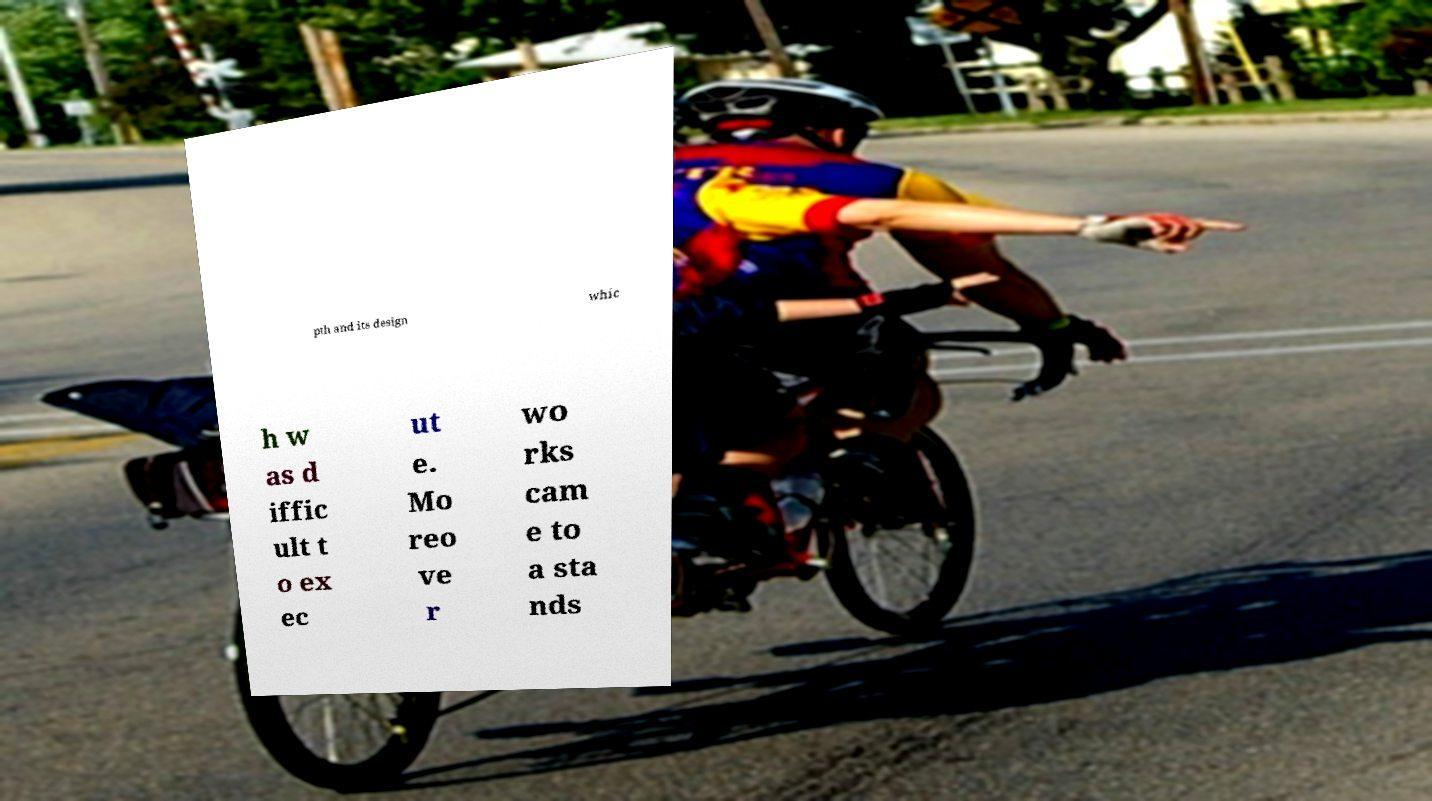Please identify and transcribe the text found in this image. pth and its design whic h w as d iffic ult t o ex ec ut e. Mo reo ve r wo rks cam e to a sta nds 